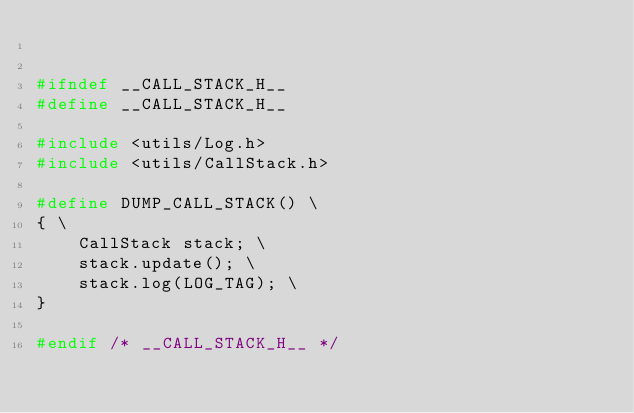Convert code to text. <code><loc_0><loc_0><loc_500><loc_500><_C_>

#ifndef __CALL_STACK_H__
#define __CALL_STACK_H__

#include <utils/Log.h>
#include <utils/CallStack.h>

#define DUMP_CALL_STACK() \
{ \
    CallStack stack; \
    stack.update(); \
    stack.log(LOG_TAG); \
}

#endif /* __CALL_STACK_H__ */


</code> 